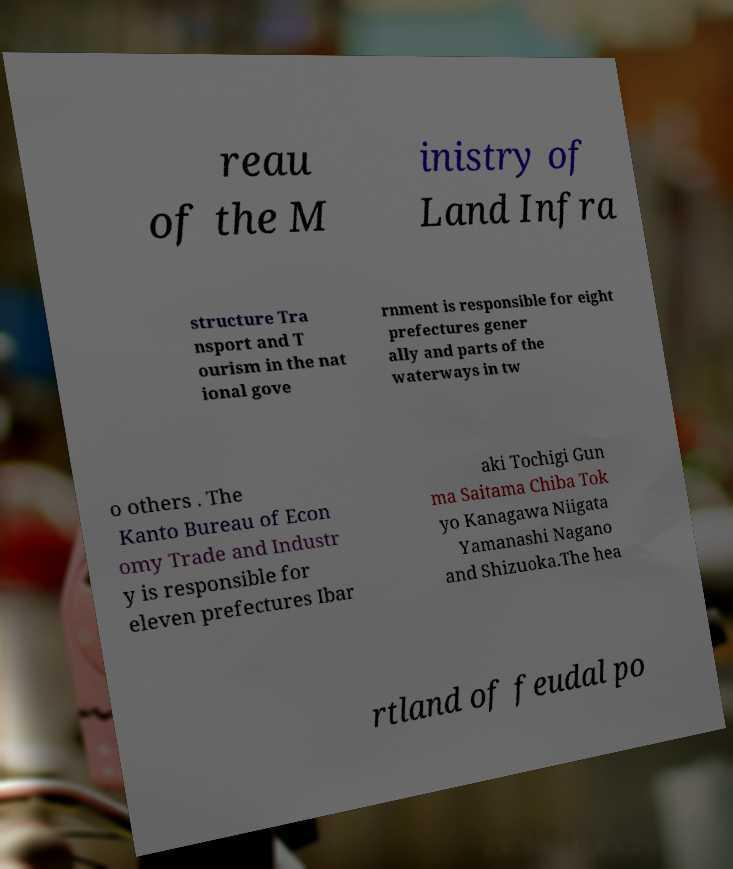For documentation purposes, I need the text within this image transcribed. Could you provide that? reau of the M inistry of Land Infra structure Tra nsport and T ourism in the nat ional gove rnment is responsible for eight prefectures gener ally and parts of the waterways in tw o others . The Kanto Bureau of Econ omy Trade and Industr y is responsible for eleven prefectures Ibar aki Tochigi Gun ma Saitama Chiba Tok yo Kanagawa Niigata Yamanashi Nagano and Shizuoka.The hea rtland of feudal po 